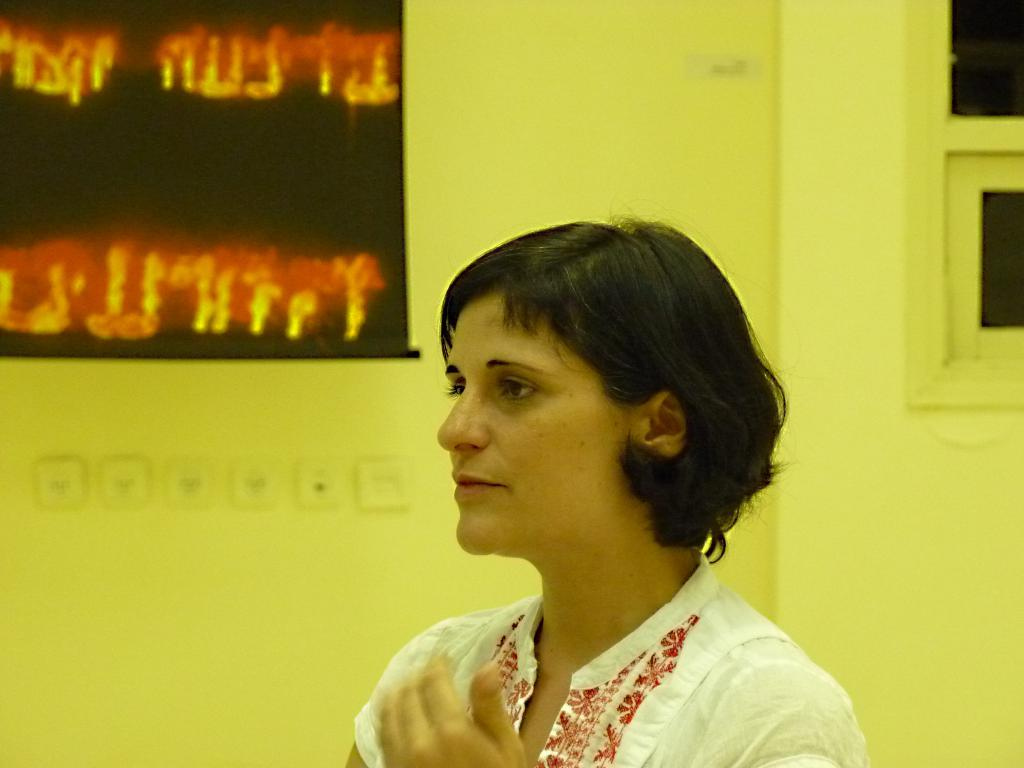Who is the main subject in the image? There is a lady in the center of the image. What can be seen in the background of the image? There is a wall in the background of the image. What is on the wall in the image? There is a poster with some text in the image. Where is the window located in the image? There is a window to the right side of the image. What type of bottle is being used for the journey in the image? There is no bottle or journey depicted in the image; it features a lady, a wall, a poster, and a window. 